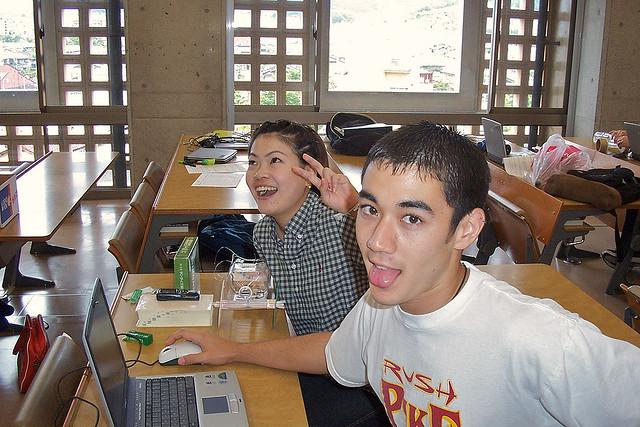Where are these young people seated? school 